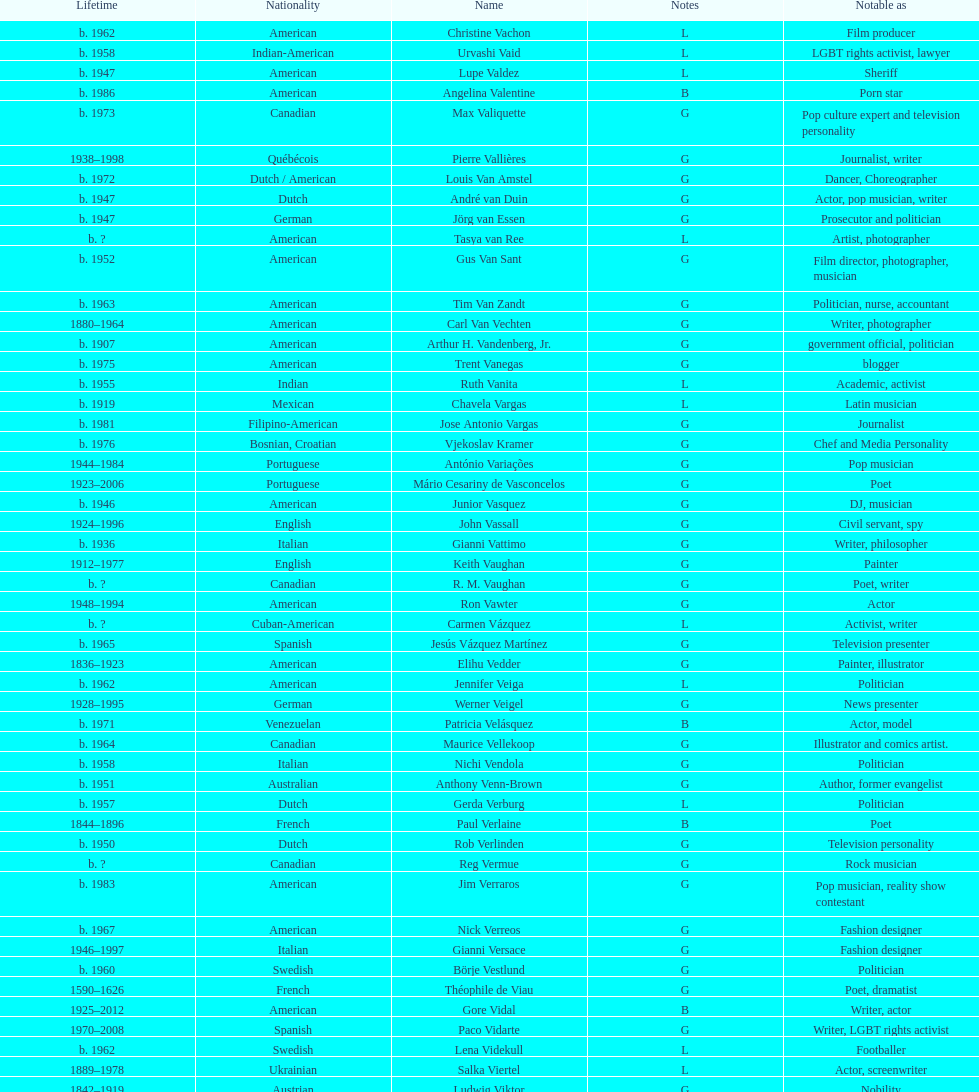Patricia velasquez and ron vawter both had what career? Actor. I'm looking to parse the entire table for insights. Could you assist me with that? {'header': ['Lifetime', 'Nationality', 'Name', 'Notes', 'Notable as'], 'rows': [['b. 1962', 'American', 'Christine Vachon', 'L', 'Film producer'], ['b. 1958', 'Indian-American', 'Urvashi Vaid', 'L', 'LGBT rights activist, lawyer'], ['b. 1947', 'American', 'Lupe Valdez', 'L', 'Sheriff'], ['b. 1986', 'American', 'Angelina Valentine', 'B', 'Porn star'], ['b. 1973', 'Canadian', 'Max Valiquette', 'G', 'Pop culture expert and television personality'], ['1938–1998', 'Québécois', 'Pierre Vallières', 'G', 'Journalist, writer'], ['b. 1972', 'Dutch / American', 'Louis Van Amstel', 'G', 'Dancer, Choreographer'], ['b. 1947', 'Dutch', 'André van Duin', 'G', 'Actor, pop musician, writer'], ['b. 1947', 'German', 'Jörg van Essen', 'G', 'Prosecutor and politician'], ['b.\xa0?', 'American', 'Tasya van Ree', 'L', 'Artist, photographer'], ['b. 1952', 'American', 'Gus Van Sant', 'G', 'Film director, photographer, musician'], ['b. 1963', 'American', 'Tim Van Zandt', 'G', 'Politician, nurse, accountant'], ['1880–1964', 'American', 'Carl Van Vechten', 'G', 'Writer, photographer'], ['b. 1907', 'American', 'Arthur H. Vandenberg, Jr.', 'G', 'government official, politician'], ['b. 1975', 'American', 'Trent Vanegas', 'G', 'blogger'], ['b. 1955', 'Indian', 'Ruth Vanita', 'L', 'Academic, activist'], ['b. 1919', 'Mexican', 'Chavela Vargas', 'L', 'Latin musician'], ['b. 1981', 'Filipino-American', 'Jose Antonio Vargas', 'G', 'Journalist'], ['b. 1976', 'Bosnian, Croatian', 'Vjekoslav Kramer', 'G', 'Chef and Media Personality'], ['1944–1984', 'Portuguese', 'António Variações', 'G', 'Pop musician'], ['1923–2006', 'Portuguese', 'Mário Cesariny de Vasconcelos', 'G', 'Poet'], ['b. 1946', 'American', 'Junior Vasquez', 'G', 'DJ, musician'], ['1924–1996', 'English', 'John Vassall', 'G', 'Civil servant, spy'], ['b. 1936', 'Italian', 'Gianni Vattimo', 'G', 'Writer, philosopher'], ['1912–1977', 'English', 'Keith Vaughan', 'G', 'Painter'], ['b.\xa0?', 'Canadian', 'R. M. Vaughan', 'G', 'Poet, writer'], ['1948–1994', 'American', 'Ron Vawter', 'G', 'Actor'], ['b.\xa0?', 'Cuban-American', 'Carmen Vázquez', 'L', 'Activist, writer'], ['b. 1965', 'Spanish', 'Jesús Vázquez Martínez', 'G', 'Television presenter'], ['1836–1923', 'American', 'Elihu Vedder', 'G', 'Painter, illustrator'], ['b. 1962', 'American', 'Jennifer Veiga', 'L', 'Politician'], ['1928–1995', 'German', 'Werner Veigel', 'G', 'News presenter'], ['b. 1971', 'Venezuelan', 'Patricia Velásquez', 'B', 'Actor, model'], ['b. 1964', 'Canadian', 'Maurice Vellekoop', 'G', 'Illustrator and comics artist.'], ['b. 1958', 'Italian', 'Nichi Vendola', 'G', 'Politician'], ['b. 1951', 'Australian', 'Anthony Venn-Brown', 'G', 'Author, former evangelist'], ['b. 1957', 'Dutch', 'Gerda Verburg', 'L', 'Politician'], ['1844–1896', 'French', 'Paul Verlaine', 'B', 'Poet'], ['b. 1950', 'Dutch', 'Rob Verlinden', 'G', 'Television personality'], ['b.\xa0?', 'Canadian', 'Reg Vermue', 'G', 'Rock musician'], ['b. 1983', 'American', 'Jim Verraros', 'G', 'Pop musician, reality show contestant'], ['b. 1967', 'American', 'Nick Verreos', 'G', 'Fashion designer'], ['1946–1997', 'Italian', 'Gianni Versace', 'G', 'Fashion designer'], ['b. 1960', 'Swedish', 'Börje Vestlund', 'G', 'Politician'], ['1590–1626', 'French', 'Théophile de Viau', 'G', 'Poet, dramatist'], ['1925–2012', 'American', 'Gore Vidal', 'B', 'Writer, actor'], ['1970–2008', 'Spanish', 'Paco Vidarte', 'G', 'Writer, LGBT rights activist'], ['b. 1962', 'Swedish', 'Lena Videkull', 'L', 'Footballer'], ['1889–1978', 'Ukrainian', 'Salka Viertel', 'L', 'Actor, screenwriter'], ['1842–1919', 'Austrian', 'Ludwig Viktor', 'G', 'Nobility'], ['b. 1948', 'American', 'Bruce Vilanch', 'G', 'Comedy writer, actor'], ['1953–1994', 'American', 'Tom Villard', 'G', 'Actor'], ['b. 1961', 'American', 'José Villarrubia', 'G', 'Artist'], ['1903–1950', 'Mexican', 'Xavier Villaurrutia', 'G', 'Poet, playwright'], ['1950–2000', 'French', "Alain-Philippe Malagnac d'Argens de Villèle", 'G', 'Aristocrat'], ['b.\xa0?', 'American', 'Norah Vincent', 'L', 'Journalist'], ['1917–1998', 'American', 'Donald Vining', 'G', 'Writer'], ['1906–1976', 'Italian', 'Luchino Visconti', 'G', 'Filmmaker'], ['b. 1962', 'Czech', 'Pavel Vítek', 'G', 'Pop musician, actor'], ['1877–1909', 'English', 'Renée Vivien', 'L', 'Poet'], ['1948–1983', 'Canadian', 'Claude Vivier', 'G', '20th century classical composer'], ['b. 1983', 'American', 'Taylor Vixen', 'B', 'Porn star'], ['1934–1994', 'American', 'Bruce Voeller', 'G', 'HIV/AIDS researcher'], ['b. 1951', 'American', 'Paula Vogel', 'L', 'Playwright'], ['b. 1985', 'Russian', 'Julia Volkova', 'B', 'Singer'], ['b. 1947', 'German', 'Jörg van Essen', 'G', 'Politician'], ['b. 1955', 'German', 'Ole von Beust', 'G', 'Politician'], ['1856–1931', 'German', 'Wilhelm von Gloeden', 'G', 'Photographer'], ['b. 1942', 'German', 'Rosa von Praunheim', 'G', 'Film director'], ['b. 1901–1996', 'German', 'Kurt von Ruffin', 'G', 'Holocaust survivor'], ['b. 1959', 'German', 'Hella von Sinnen', 'L', 'Comedian'], ['b. 1981', 'American', 'Daniel Vosovic', 'G', 'Fashion designer'], ['b. 1966', 'Canadian', 'Delwin Vriend', 'G', 'LGBT rights activist']]} 